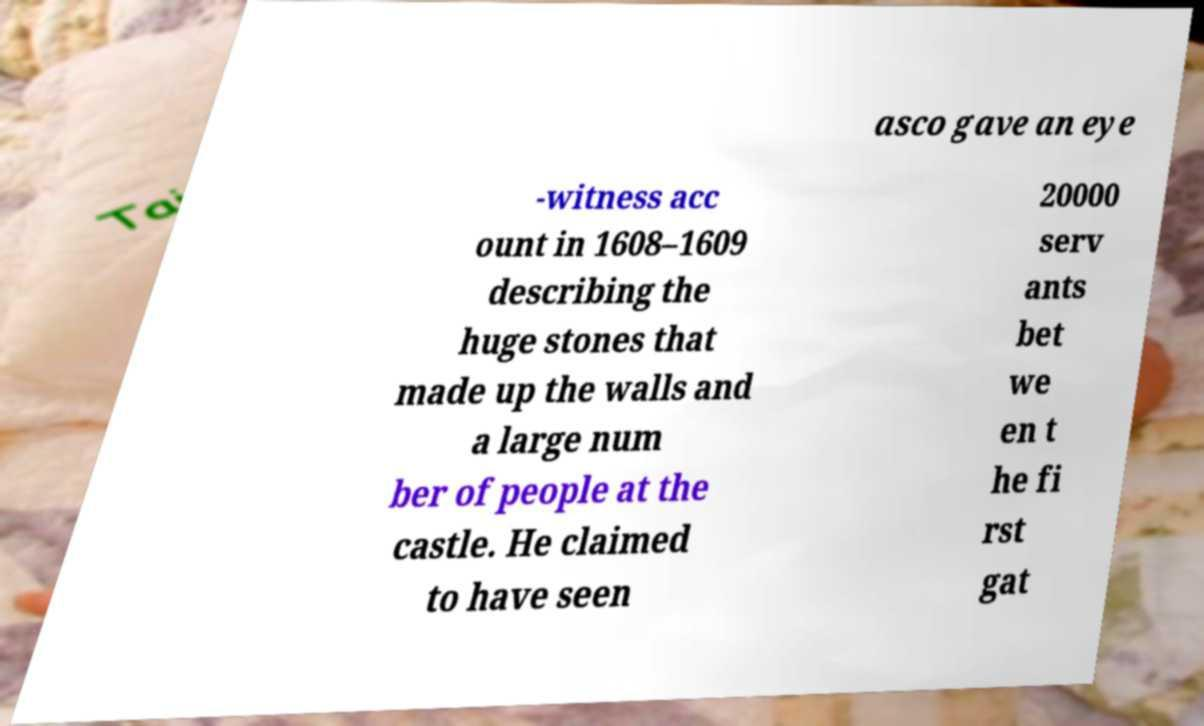There's text embedded in this image that I need extracted. Can you transcribe it verbatim? asco gave an eye -witness acc ount in 1608–1609 describing the huge stones that made up the walls and a large num ber of people at the castle. He claimed to have seen 20000 serv ants bet we en t he fi rst gat 